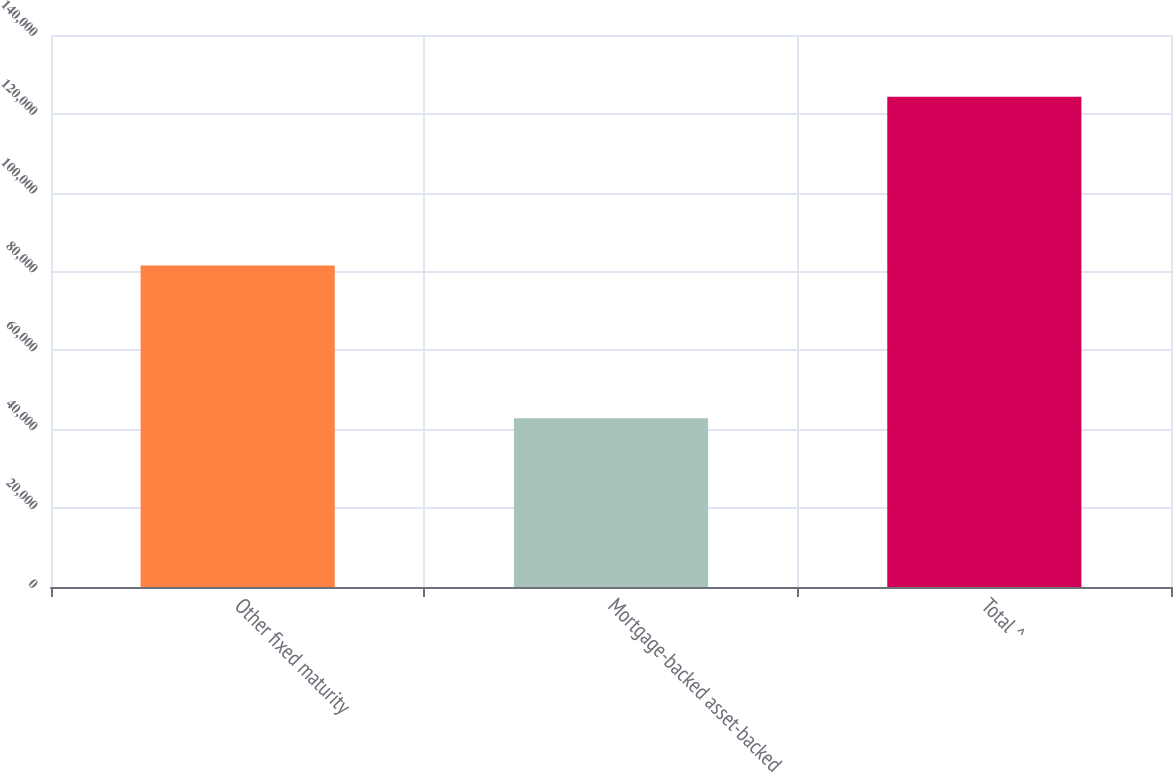Convert chart to OTSL. <chart><loc_0><loc_0><loc_500><loc_500><bar_chart><fcel>Other fixed maturity<fcel>Mortgage-backed asset-backed<fcel>Total ^<nl><fcel>81571<fcel>42776<fcel>124347<nl></chart> 